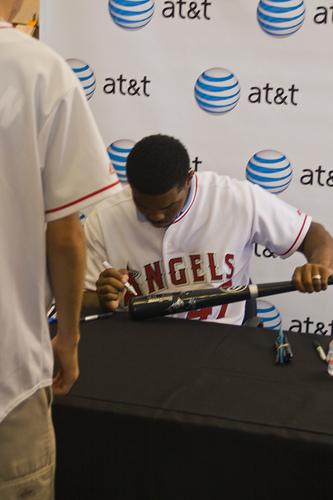What is the athlete doing?
Answer briefly. Signing. What team does the baseball players shirt say?
Short answer required. Angels. What sport does this person play?
Quick response, please. Baseball. 